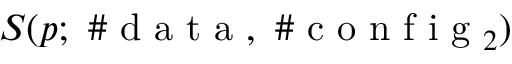<formula> <loc_0><loc_0><loc_500><loc_500>S ( p ; \# d a t a , \# c o n f i g _ { 2 } )</formula> 